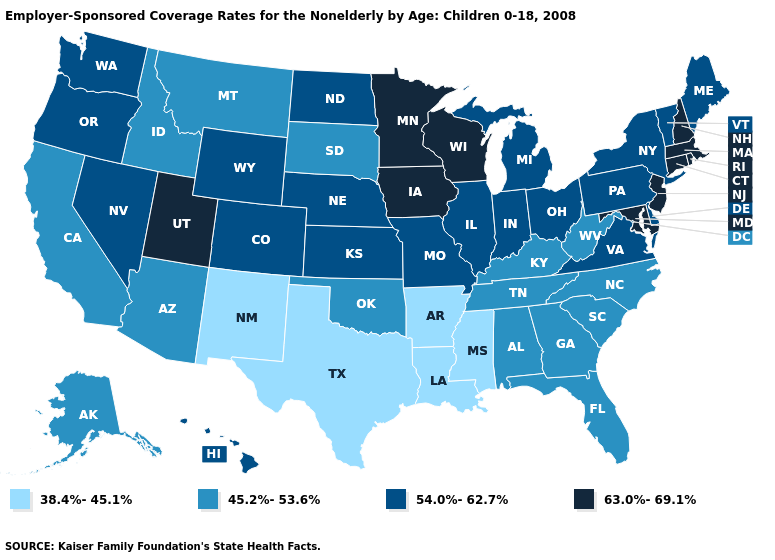Name the states that have a value in the range 38.4%-45.1%?
Short answer required. Arkansas, Louisiana, Mississippi, New Mexico, Texas. Does the first symbol in the legend represent the smallest category?
Give a very brief answer. Yes. Name the states that have a value in the range 54.0%-62.7%?
Short answer required. Colorado, Delaware, Hawaii, Illinois, Indiana, Kansas, Maine, Michigan, Missouri, Nebraska, Nevada, New York, North Dakota, Ohio, Oregon, Pennsylvania, Vermont, Virginia, Washington, Wyoming. What is the value of North Carolina?
Give a very brief answer. 45.2%-53.6%. Does Pennsylvania have the same value as Nebraska?
Short answer required. Yes. Among the states that border Montana , does North Dakota have the lowest value?
Give a very brief answer. No. How many symbols are there in the legend?
Short answer required. 4. Does Colorado have the highest value in the USA?
Concise answer only. No. What is the lowest value in states that border Illinois?
Quick response, please. 45.2%-53.6%. What is the highest value in the USA?
Be succinct. 63.0%-69.1%. What is the value of South Carolina?
Write a very short answer. 45.2%-53.6%. What is the value of Indiana?
Write a very short answer. 54.0%-62.7%. What is the highest value in the USA?
Write a very short answer. 63.0%-69.1%. Which states have the lowest value in the USA?
Write a very short answer. Arkansas, Louisiana, Mississippi, New Mexico, Texas. Does Wisconsin have the highest value in the MidWest?
Write a very short answer. Yes. 